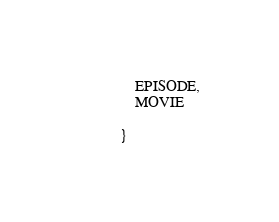Convert code to text. <code><loc_0><loc_0><loc_500><loc_500><_Java_>	EPISODE,
	MOVIE

}
</code> 